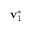<formula> <loc_0><loc_0><loc_500><loc_500>v _ { 1 } ^ { * }</formula> 